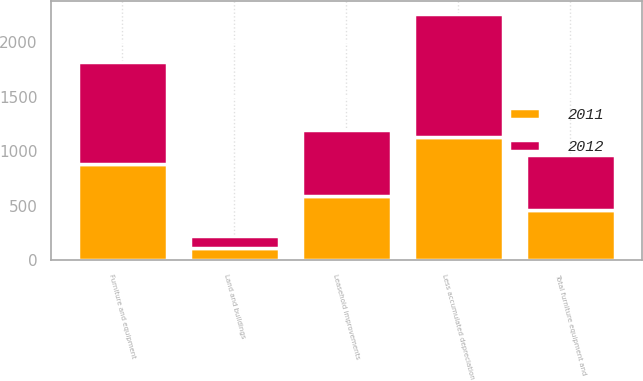Convert chart to OTSL. <chart><loc_0><loc_0><loc_500><loc_500><stacked_bar_chart><ecel><fcel>Furniture and equipment<fcel>Leasehold improvements<fcel>Land and buildings<fcel>Less accumulated depreciation<fcel>Total furniture equipment and<nl><fcel>2012<fcel>932.6<fcel>597.2<fcel>109.9<fcel>1134.9<fcel>504.8<nl><fcel>2011<fcel>881.5<fcel>593<fcel>111.6<fcel>1126.3<fcel>459.8<nl></chart> 